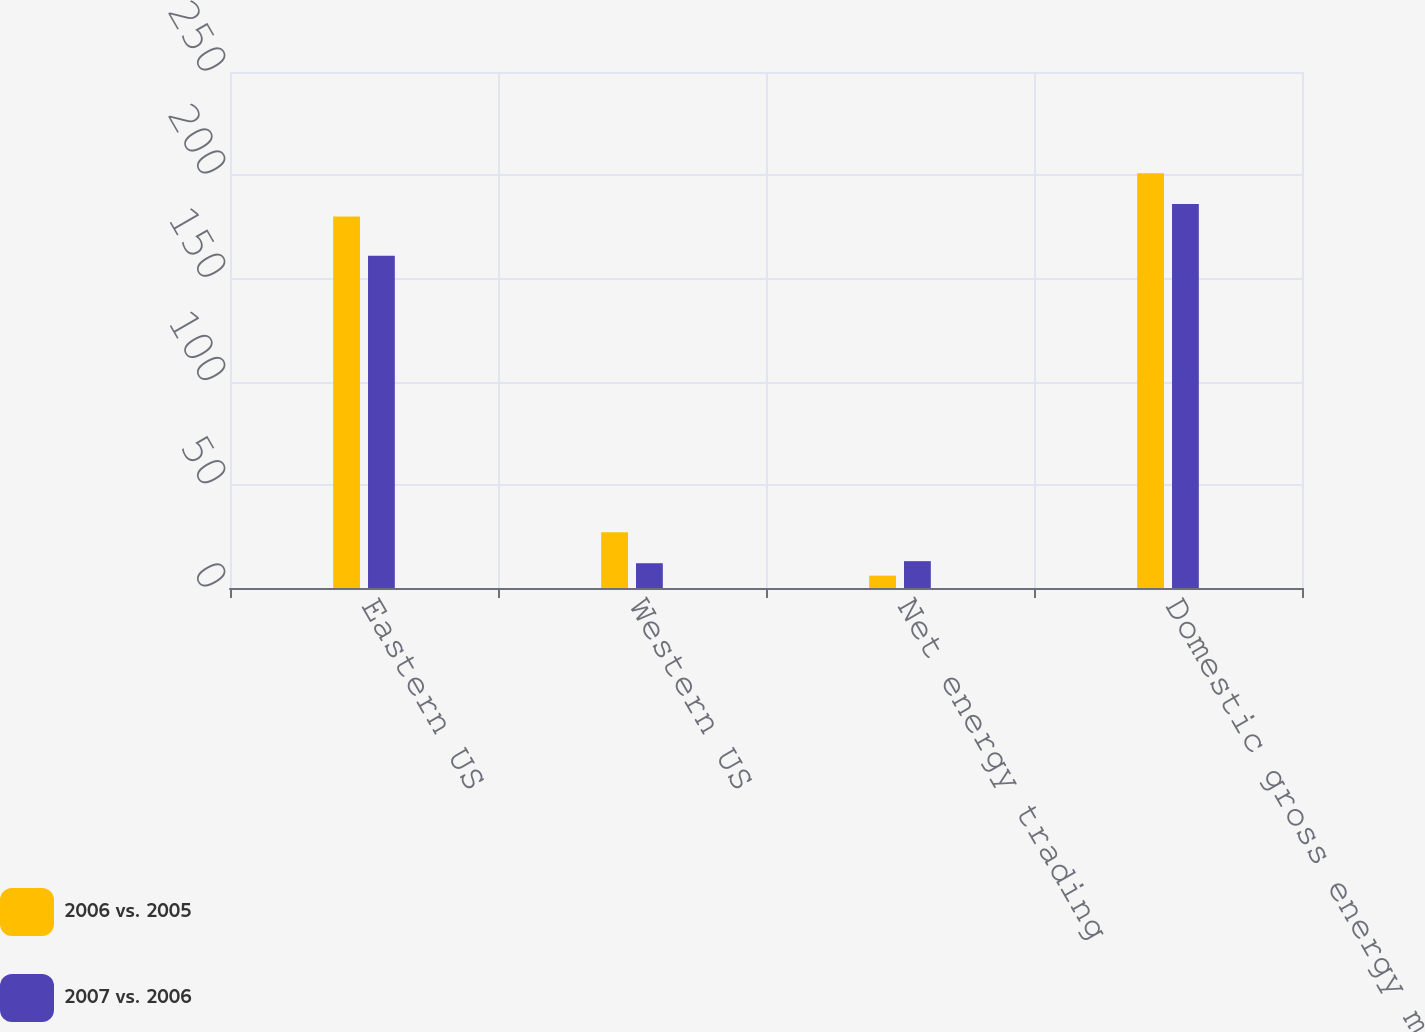Convert chart to OTSL. <chart><loc_0><loc_0><loc_500><loc_500><stacked_bar_chart><ecel><fcel>Eastern US<fcel>Western US<fcel>Net energy trading<fcel>Domestic gross energy margins<nl><fcel>2006 vs. 2005<fcel>180<fcel>27<fcel>6<fcel>201<nl><fcel>2007 vs. 2006<fcel>161<fcel>12<fcel>13<fcel>186<nl></chart> 